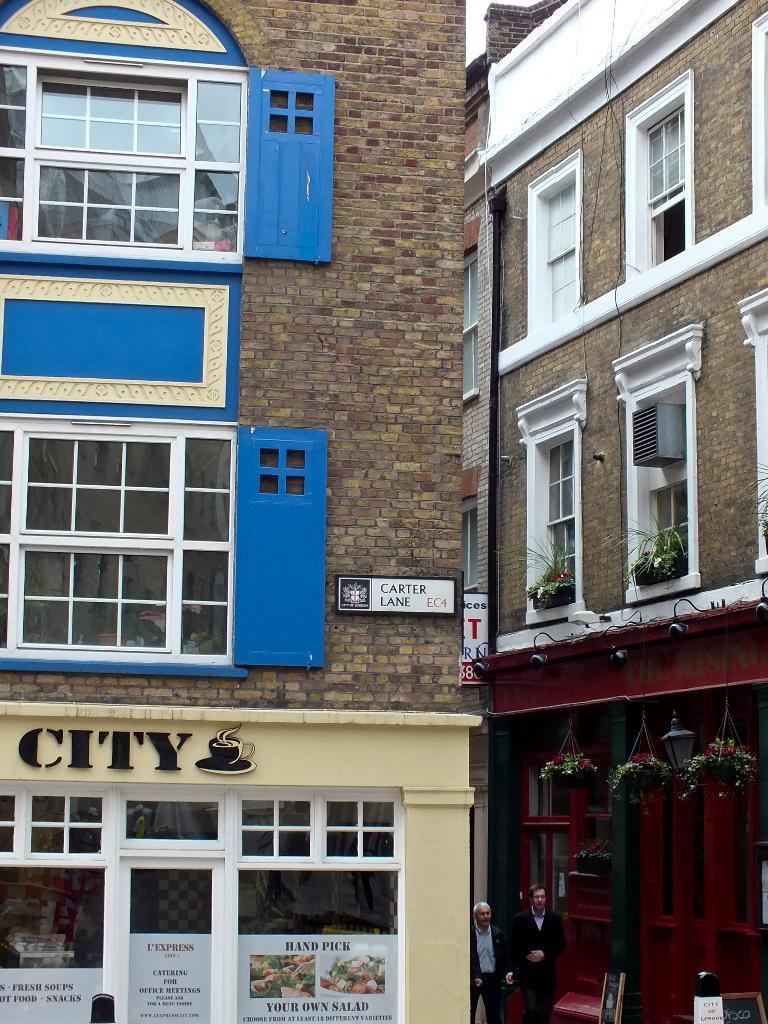Could you give a brief overview of what you see in this image? In this image we can see buildings and there are two people walking in the middle of the buildings. There is a shop which looks like a cafe and there are some posters attached to the walls. We can also see some plants in flower pots. 